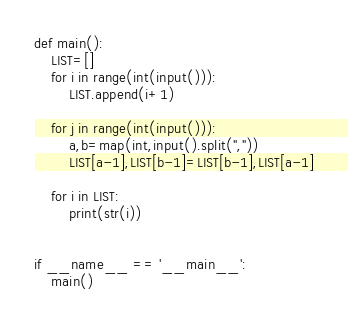Convert code to text. <code><loc_0><loc_0><loc_500><loc_500><_Python_>def main():
    LIST=[]
    for i in range(int(input())):
        LIST.append(i+1)

    for j in range(int(input())):
        a,b=map(int,input().split(","))
        LIST[a-1],LIST[b-1]=LIST[b-1],LIST[a-1]

    for i in LIST:
        print(str(i))
            
    
if __name__ == '__main__':
    main()</code> 